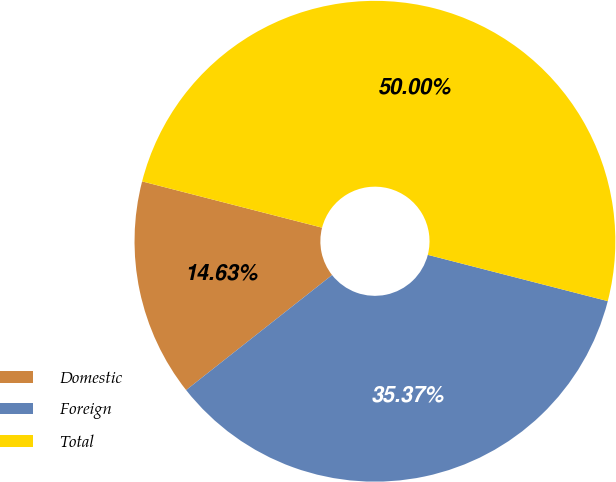Convert chart to OTSL. <chart><loc_0><loc_0><loc_500><loc_500><pie_chart><fcel>Domestic<fcel>Foreign<fcel>Total<nl><fcel>14.63%<fcel>35.37%<fcel>50.0%<nl></chart> 